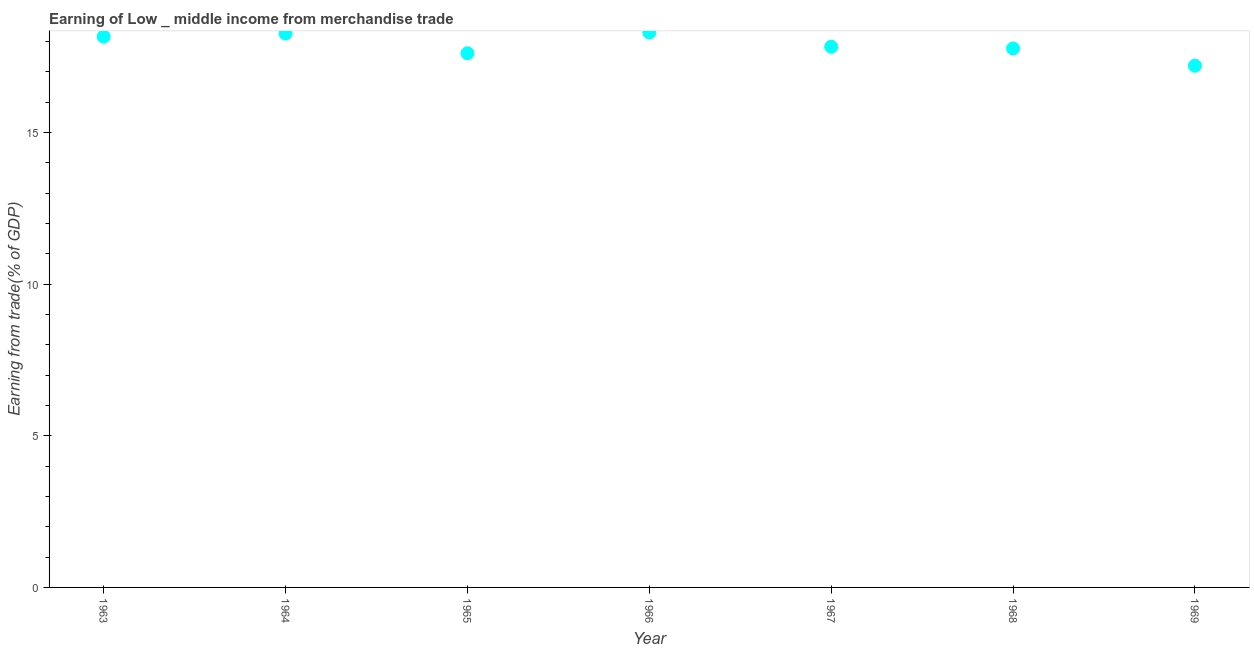What is the earning from merchandise trade in 1963?
Keep it short and to the point. 18.16. Across all years, what is the maximum earning from merchandise trade?
Ensure brevity in your answer.  18.3. Across all years, what is the minimum earning from merchandise trade?
Your answer should be compact. 17.2. In which year was the earning from merchandise trade maximum?
Keep it short and to the point. 1966. In which year was the earning from merchandise trade minimum?
Offer a terse response. 1969. What is the sum of the earning from merchandise trade?
Your answer should be very brief. 125.13. What is the difference between the earning from merchandise trade in 1963 and 1969?
Offer a terse response. 0.96. What is the average earning from merchandise trade per year?
Your answer should be very brief. 17.88. What is the median earning from merchandise trade?
Make the answer very short. 17.83. In how many years, is the earning from merchandise trade greater than 12 %?
Your answer should be very brief. 7. What is the ratio of the earning from merchandise trade in 1964 to that in 1967?
Offer a very short reply. 1.02. What is the difference between the highest and the second highest earning from merchandise trade?
Keep it short and to the point. 0.03. Is the sum of the earning from merchandise trade in 1964 and 1966 greater than the maximum earning from merchandise trade across all years?
Your answer should be compact. Yes. What is the difference between the highest and the lowest earning from merchandise trade?
Keep it short and to the point. 1.1. Does the earning from merchandise trade monotonically increase over the years?
Your answer should be compact. No. How many dotlines are there?
Your answer should be compact. 1. How many years are there in the graph?
Your answer should be very brief. 7. Does the graph contain any zero values?
Keep it short and to the point. No. What is the title of the graph?
Offer a terse response. Earning of Low _ middle income from merchandise trade. What is the label or title of the X-axis?
Make the answer very short. Year. What is the label or title of the Y-axis?
Provide a short and direct response. Earning from trade(% of GDP). What is the Earning from trade(% of GDP) in 1963?
Provide a short and direct response. 18.16. What is the Earning from trade(% of GDP) in 1964?
Offer a terse response. 18.26. What is the Earning from trade(% of GDP) in 1965?
Provide a short and direct response. 17.61. What is the Earning from trade(% of GDP) in 1966?
Give a very brief answer. 18.3. What is the Earning from trade(% of GDP) in 1967?
Your answer should be very brief. 17.83. What is the Earning from trade(% of GDP) in 1968?
Your answer should be very brief. 17.77. What is the Earning from trade(% of GDP) in 1969?
Keep it short and to the point. 17.2. What is the difference between the Earning from trade(% of GDP) in 1963 and 1964?
Offer a very short reply. -0.1. What is the difference between the Earning from trade(% of GDP) in 1963 and 1965?
Keep it short and to the point. 0.55. What is the difference between the Earning from trade(% of GDP) in 1963 and 1966?
Make the answer very short. -0.14. What is the difference between the Earning from trade(% of GDP) in 1963 and 1967?
Your answer should be very brief. 0.33. What is the difference between the Earning from trade(% of GDP) in 1963 and 1968?
Provide a short and direct response. 0.39. What is the difference between the Earning from trade(% of GDP) in 1963 and 1969?
Provide a succinct answer. 0.96. What is the difference between the Earning from trade(% of GDP) in 1964 and 1965?
Your response must be concise. 0.65. What is the difference between the Earning from trade(% of GDP) in 1964 and 1966?
Offer a very short reply. -0.03. What is the difference between the Earning from trade(% of GDP) in 1964 and 1967?
Offer a terse response. 0.44. What is the difference between the Earning from trade(% of GDP) in 1964 and 1968?
Offer a terse response. 0.49. What is the difference between the Earning from trade(% of GDP) in 1964 and 1969?
Make the answer very short. 1.06. What is the difference between the Earning from trade(% of GDP) in 1965 and 1966?
Provide a short and direct response. -0.69. What is the difference between the Earning from trade(% of GDP) in 1965 and 1967?
Offer a terse response. -0.21. What is the difference between the Earning from trade(% of GDP) in 1965 and 1968?
Keep it short and to the point. -0.16. What is the difference between the Earning from trade(% of GDP) in 1965 and 1969?
Provide a succinct answer. 0.41. What is the difference between the Earning from trade(% of GDP) in 1966 and 1967?
Keep it short and to the point. 0.47. What is the difference between the Earning from trade(% of GDP) in 1966 and 1968?
Your answer should be compact. 0.53. What is the difference between the Earning from trade(% of GDP) in 1966 and 1969?
Provide a succinct answer. 1.1. What is the difference between the Earning from trade(% of GDP) in 1967 and 1968?
Ensure brevity in your answer.  0.06. What is the difference between the Earning from trade(% of GDP) in 1967 and 1969?
Make the answer very short. 0.62. What is the difference between the Earning from trade(% of GDP) in 1968 and 1969?
Your response must be concise. 0.57. What is the ratio of the Earning from trade(% of GDP) in 1963 to that in 1965?
Give a very brief answer. 1.03. What is the ratio of the Earning from trade(% of GDP) in 1963 to that in 1969?
Keep it short and to the point. 1.06. What is the ratio of the Earning from trade(% of GDP) in 1964 to that in 1966?
Ensure brevity in your answer.  1. What is the ratio of the Earning from trade(% of GDP) in 1964 to that in 1968?
Give a very brief answer. 1.03. What is the ratio of the Earning from trade(% of GDP) in 1964 to that in 1969?
Your answer should be compact. 1.06. What is the ratio of the Earning from trade(% of GDP) in 1965 to that in 1966?
Provide a short and direct response. 0.96. What is the ratio of the Earning from trade(% of GDP) in 1965 to that in 1968?
Provide a succinct answer. 0.99. What is the ratio of the Earning from trade(% of GDP) in 1966 to that in 1969?
Your answer should be compact. 1.06. What is the ratio of the Earning from trade(% of GDP) in 1967 to that in 1968?
Offer a very short reply. 1. What is the ratio of the Earning from trade(% of GDP) in 1967 to that in 1969?
Offer a terse response. 1.04. What is the ratio of the Earning from trade(% of GDP) in 1968 to that in 1969?
Provide a succinct answer. 1.03. 